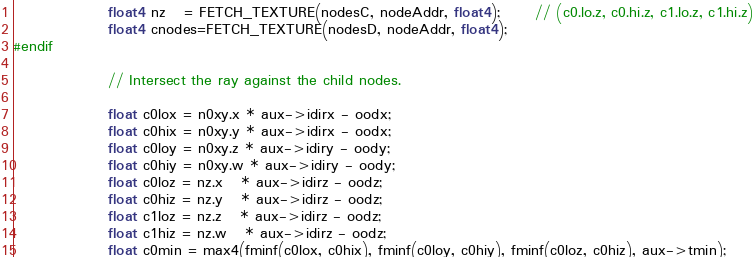<code> <loc_0><loc_0><loc_500><loc_500><_Cuda_>                float4 nz   = FETCH_TEXTURE(nodesC, nodeAddr, float4);      // (c0.lo.z, c0.hi.z, c1.lo.z, c1.hi.z)
                float4 cnodes=FETCH_TEXTURE(nodesD, nodeAddr, float4);
#endif

                // Intersect the ray against the child nodes.

                float c0lox = n0xy.x * aux->idirx - oodx;
                float c0hix = n0xy.y * aux->idirx - oodx;
                float c0loy = n0xy.z * aux->idiry - oody;
                float c0hiy = n0xy.w * aux->idiry - oody;
                float c0loz = nz.x   * aux->idirz - oodz;
                float c0hiz = nz.y   * aux->idirz - oodz;
                float c1loz = nz.z   * aux->idirz - oodz;
                float c1hiz = nz.w   * aux->idirz - oodz;
                float c0min = max4(fminf(c0lox, c0hix), fminf(c0loy, c0hiy), fminf(c0loz, c0hiz), aux->tmin);</code> 